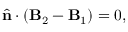Convert formula to latex. <formula><loc_0><loc_0><loc_500><loc_500>\hat { n } \cdot ( B _ { 2 } - B _ { 1 } ) = 0 ,</formula> 